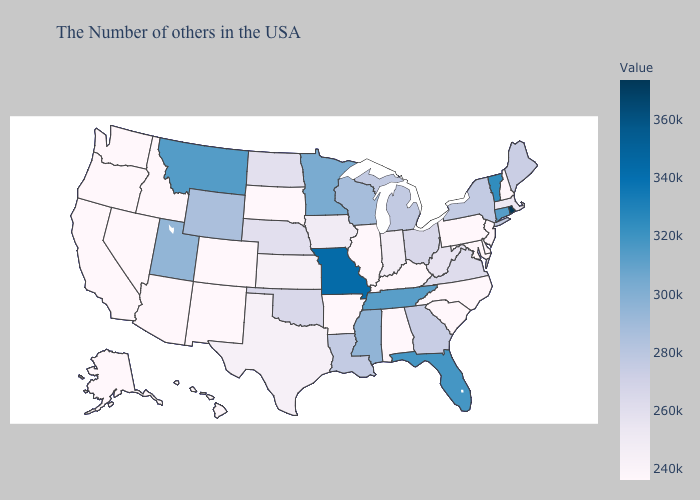Which states have the lowest value in the Northeast?
Write a very short answer. New Hampshire, New Jersey, Pennsylvania. Among the states that border Alabama , which have the lowest value?
Answer briefly. Georgia. 